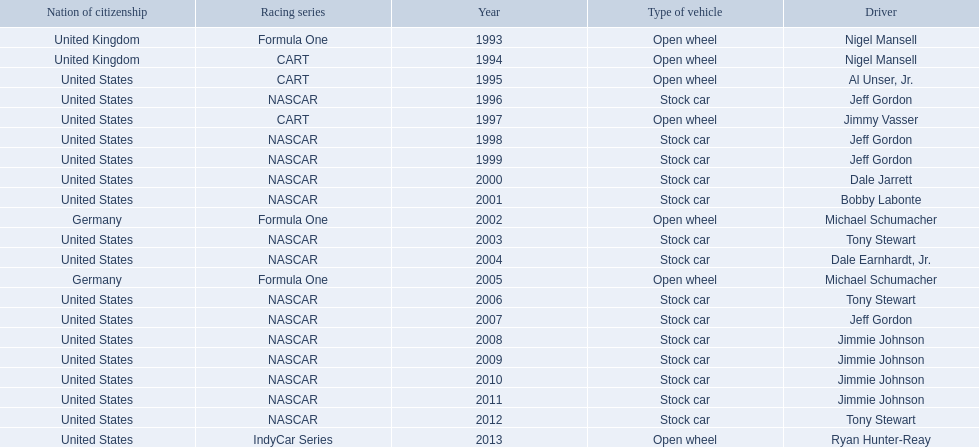Which drivers have won the best driver espy award? Nigel Mansell, Nigel Mansell, Al Unser, Jr., Jeff Gordon, Jimmy Vasser, Jeff Gordon, Jeff Gordon, Dale Jarrett, Bobby Labonte, Michael Schumacher, Tony Stewart, Dale Earnhardt, Jr., Michael Schumacher, Tony Stewart, Jeff Gordon, Jimmie Johnson, Jimmie Johnson, Jimmie Johnson, Jimmie Johnson, Tony Stewart, Ryan Hunter-Reay. Of these, which only appear once? Al Unser, Jr., Jimmy Vasser, Dale Jarrett, Dale Earnhardt, Jr., Ryan Hunter-Reay. Which of these are from the cart racing series? Al Unser, Jr., Jimmy Vasser. Of these, which received their award first? Al Unser, Jr. 